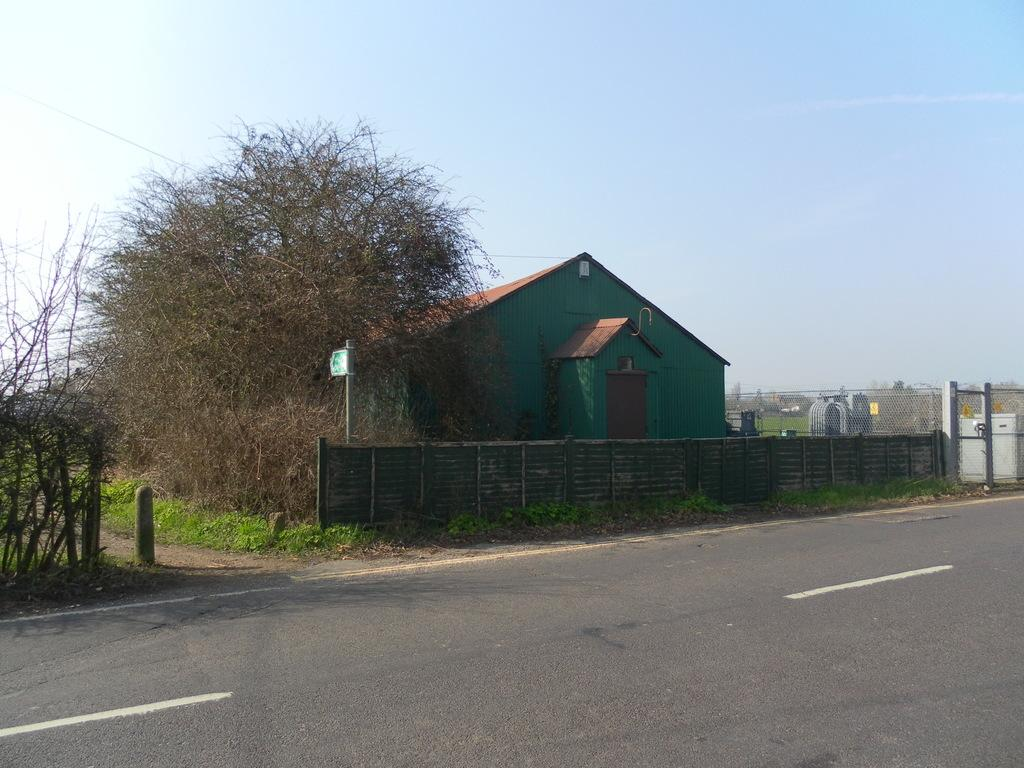What type of structure is in the image? There is a house in the image. What is the ground surface like in the image? The ground with grass is visible in the image. What type of vegetation can be seen in the image? There are trees and plants in the image. What type of barrier is present in the image? There is fencing in the image. What type of pathway is in the image? There is a road in the image. What type of electrical equipment is in the image? A transformer is present in the image. What type of objects made of metal can be seen in the image? There are metallic objects in the image. What part of the natural environment is visible in the image? The sky is visible in the image. What type of quilt is draped over the house in the image? There is no quilt draped over the house in the image. What type of lipstick is the tree wearing in the image? There are no lips or lipstick present in the image, as trees do not have the ability to wear makeup. 